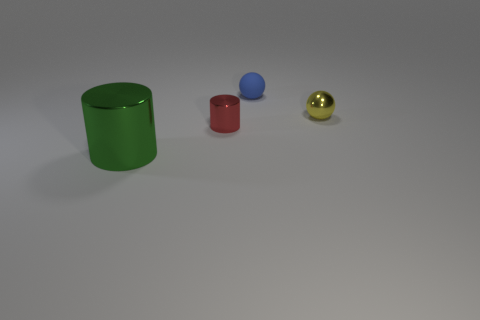There is a small metal thing to the right of the tiny red metallic object; is its color the same as the rubber thing?
Offer a very short reply. No. What number of matte balls are in front of the matte ball?
Keep it short and to the point. 0. Do the blue ball and the tiny thing in front of the tiny metallic ball have the same material?
Give a very brief answer. No. What is the size of the other cylinder that is made of the same material as the red cylinder?
Give a very brief answer. Large. Is the number of rubber spheres that are in front of the big green shiny thing greater than the number of yellow metallic things that are on the left side of the small blue ball?
Your answer should be compact. No. Are there any tiny gray metal objects that have the same shape as the tiny yellow metal object?
Offer a terse response. No. Do the thing that is behind the yellow ball and the green metallic cylinder have the same size?
Your answer should be compact. No. Are any purple matte objects visible?
Your answer should be compact. No. How many things are either big metal cylinders in front of the blue object or small matte things?
Your answer should be compact. 2. Does the matte ball have the same color as the sphere that is in front of the blue sphere?
Give a very brief answer. No. 